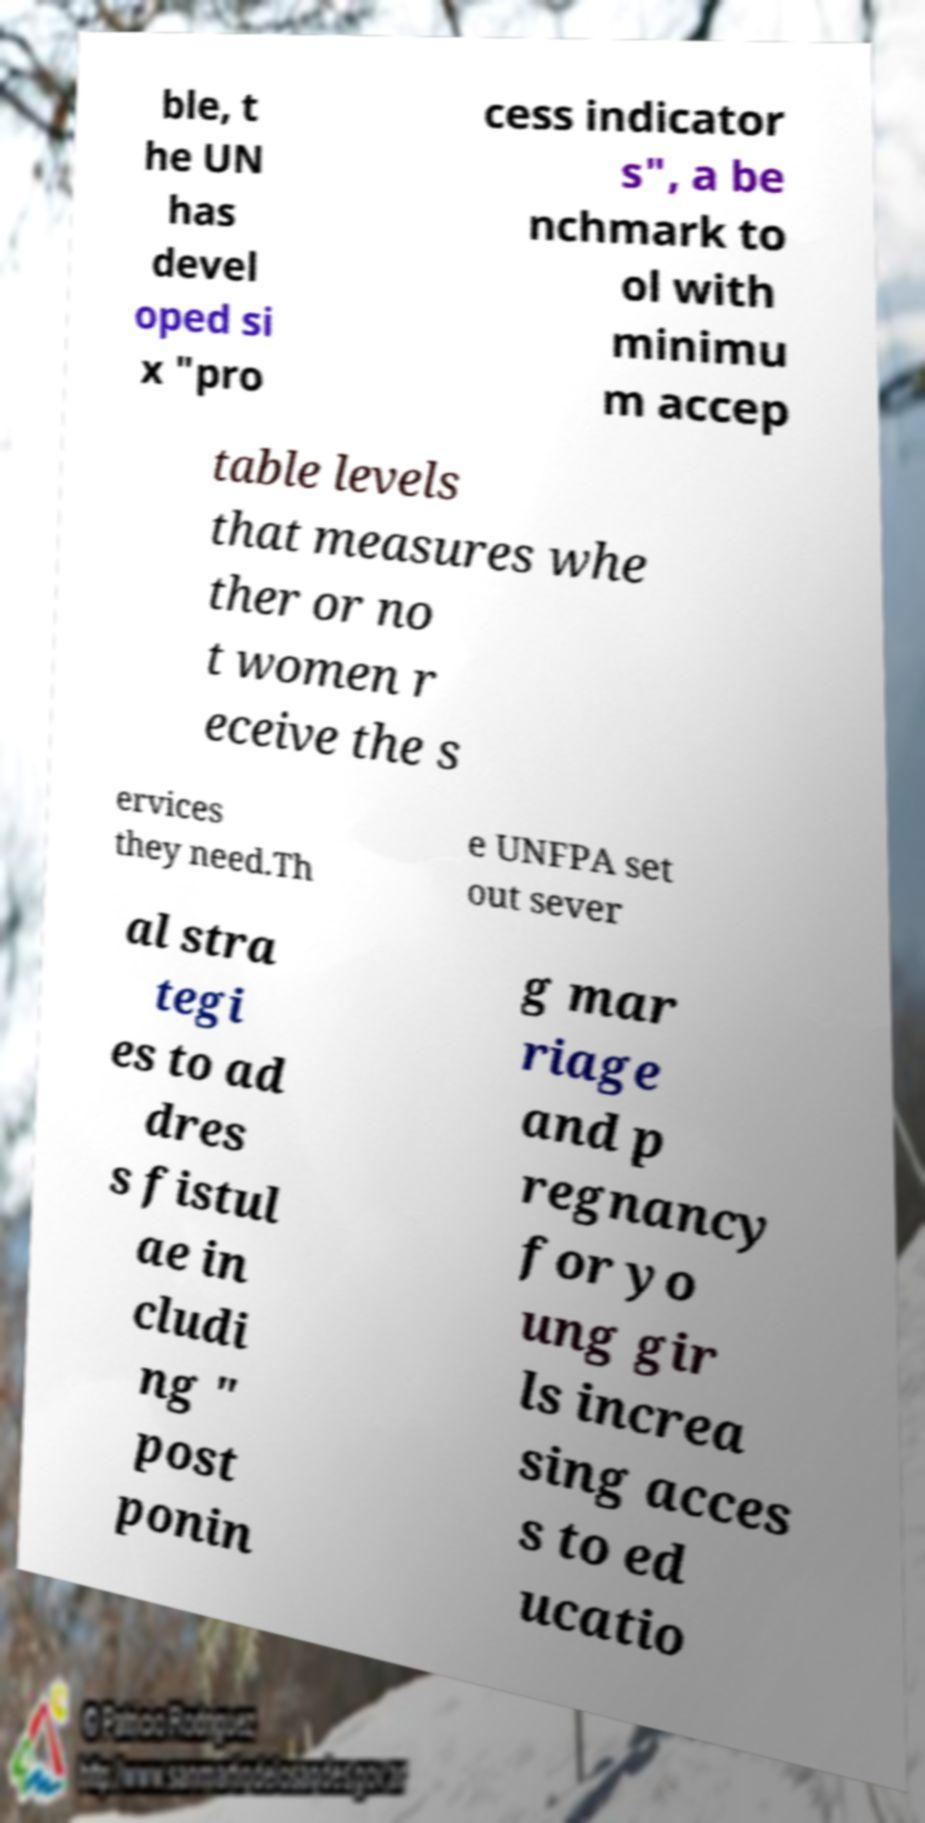There's text embedded in this image that I need extracted. Can you transcribe it verbatim? ble, t he UN has devel oped si x "pro cess indicator s", a be nchmark to ol with minimu m accep table levels that measures whe ther or no t women r eceive the s ervices they need.Th e UNFPA set out sever al stra tegi es to ad dres s fistul ae in cludi ng " post ponin g mar riage and p regnancy for yo ung gir ls increa sing acces s to ed ucatio 